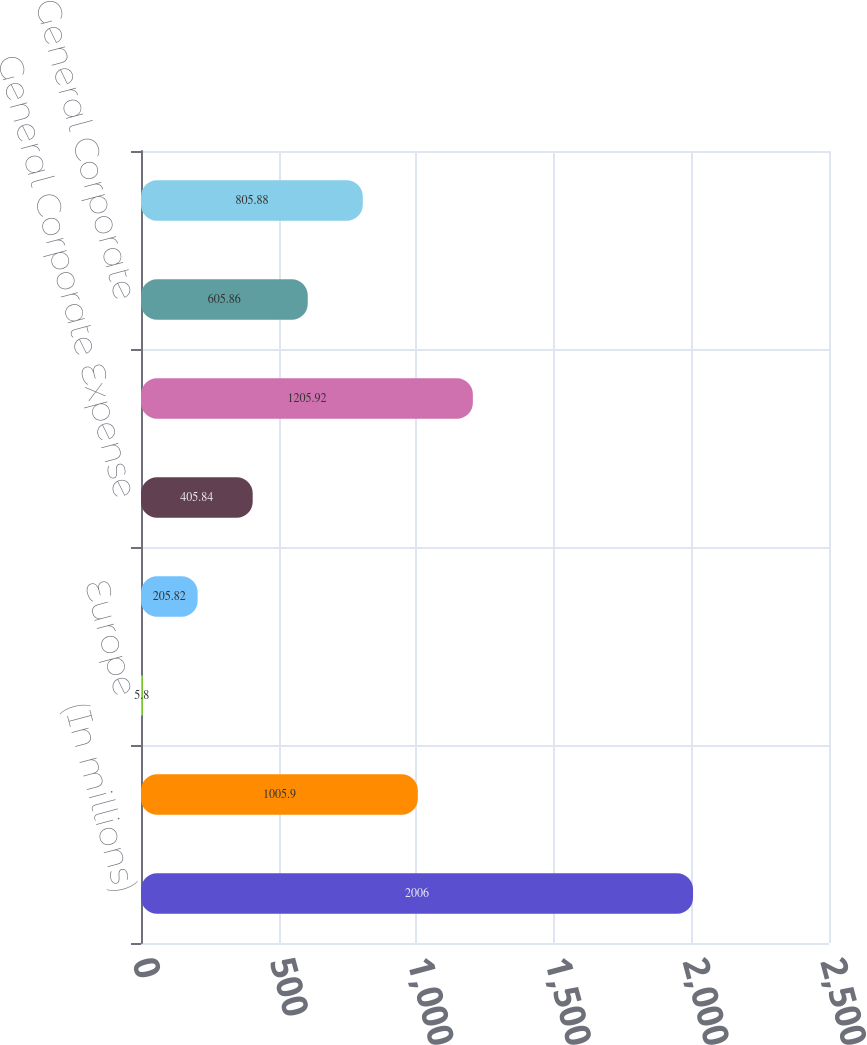Convert chart. <chart><loc_0><loc_0><loc_500><loc_500><bar_chart><fcel>(In millions)<fcel>North America<fcel>Europe<fcel>Latin America<fcel>General Corporate Expense<fcel>Total depreciation and<fcel>General Corporate<fcel>Total capital expenditures<nl><fcel>2006<fcel>1005.9<fcel>5.8<fcel>205.82<fcel>405.84<fcel>1205.92<fcel>605.86<fcel>805.88<nl></chart> 